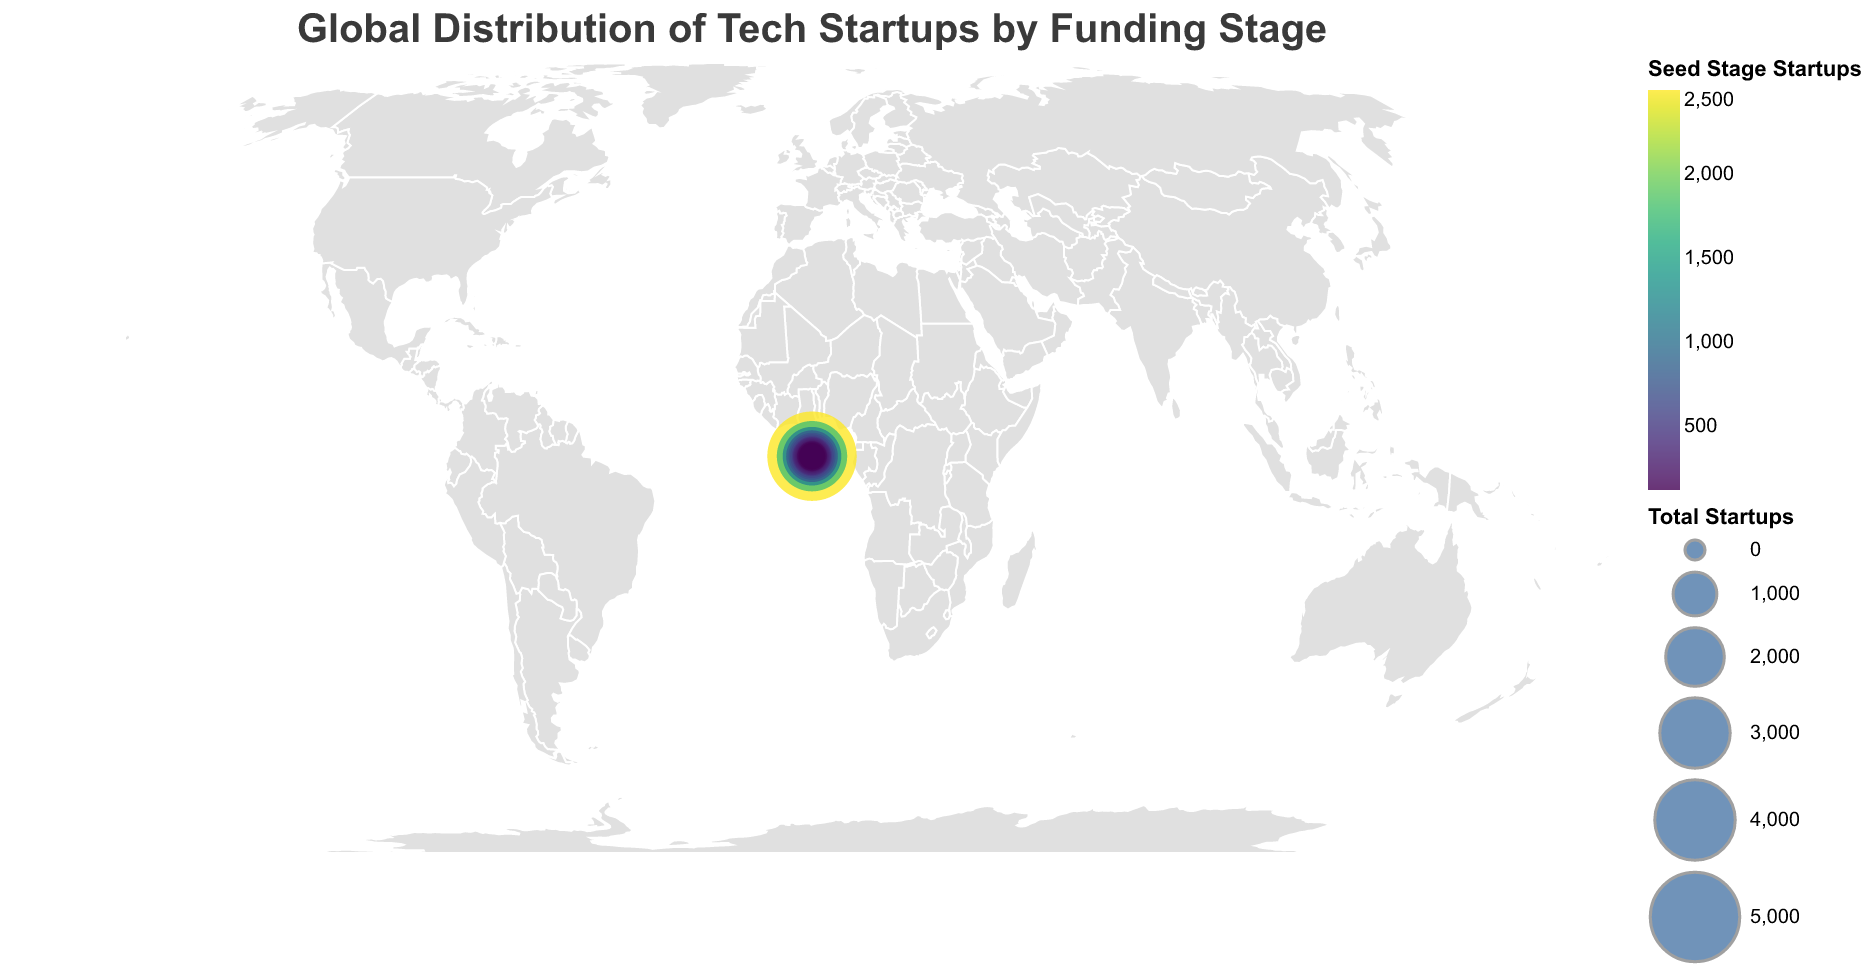Which country has the highest number of tech startups? The size of the circles is proportional to the total number of startups. The United States has the largest circle indicating the highest number of startups.
Answer: United States What is the color of the circle representing tech startups in Germany? The color represents the number of Seed Stage startups. By looking at the legend and matching the color, Germany’s circle color corresponds to the count of Seed Stage startups it has.
Answer: Darker shade of green (Viridis color palette) Which country has more startups at the Series B stage, India or the United Kingdom? The tooltip or the size of the bar segments in the plot can be used to compare the number of startups in the Series B stage between the two countries. India's Series B count is 200, which is higher than the United Kingdom's count of 200.
Answer: India What is the average number of Series A startups in the top 5 countries? The top 5 countries by the total number of startups are the United States, China, India, United Kingdom, and Germany. Their Series A counts are 1500, 800, 500, 400, and 300 respectively. Sum these numbers and divide by 5 to get the average. (1500 + 800 + 500 + 400 + 300) / 5 = 700
Answer: 700 Which country has the fewest Series C+ startups? The tooltip or the smallest segment of the bars representing Series C+ startups can help identify the country. Several countries (Brazil, Sweden, Netherlands, Japan, Australia, Spain) have the minimum value of 5 for Series C+ startups.
Answer: Brazil, Sweden, Netherlands, Japan, Australia, Spain How many more Seed Stage startups does the United States have compared to China? Referring to the tooltip, the Seed Stage startups for the United States are 2500 and for China are 1800. Subtract China's count from the United States' count to find the difference. 2500 - 1800 = 700
Answer: 700 What trend can be observed regarding the proportion of Seed Stage startups among the total startups? Analyzing the color gradient within circles and the size of circles reveals that countries with larger total startup numbers tend to have a substantial proportion in the Seed Stage. This implies early-stage investment is more common in countries with larger total counts of startups.
Answer: Higher proportion in larger total startups Among the listed countries, which has the highest series A to Series C+ startups ratio? Calculate the ratio by dividing the number of Series A startups by the number of Series C+ startups for each country. Compare these ratios to find the highest. For instance, the United States ratio is 1500/300 = 5. China’s is 800/100 = 8.
Answer: China 